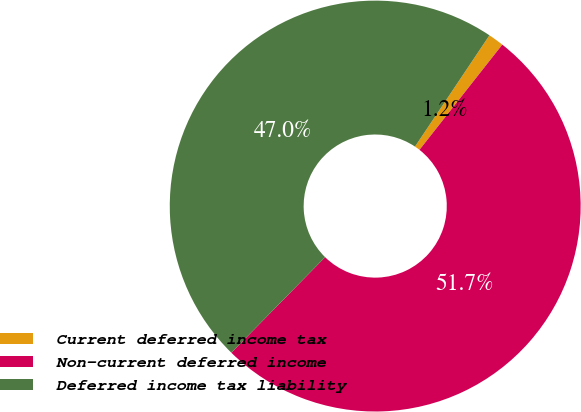Convert chart to OTSL. <chart><loc_0><loc_0><loc_500><loc_500><pie_chart><fcel>Current deferred income tax<fcel>Non-current deferred income<fcel>Deferred income tax liability<nl><fcel>1.23%<fcel>51.73%<fcel>47.03%<nl></chart> 